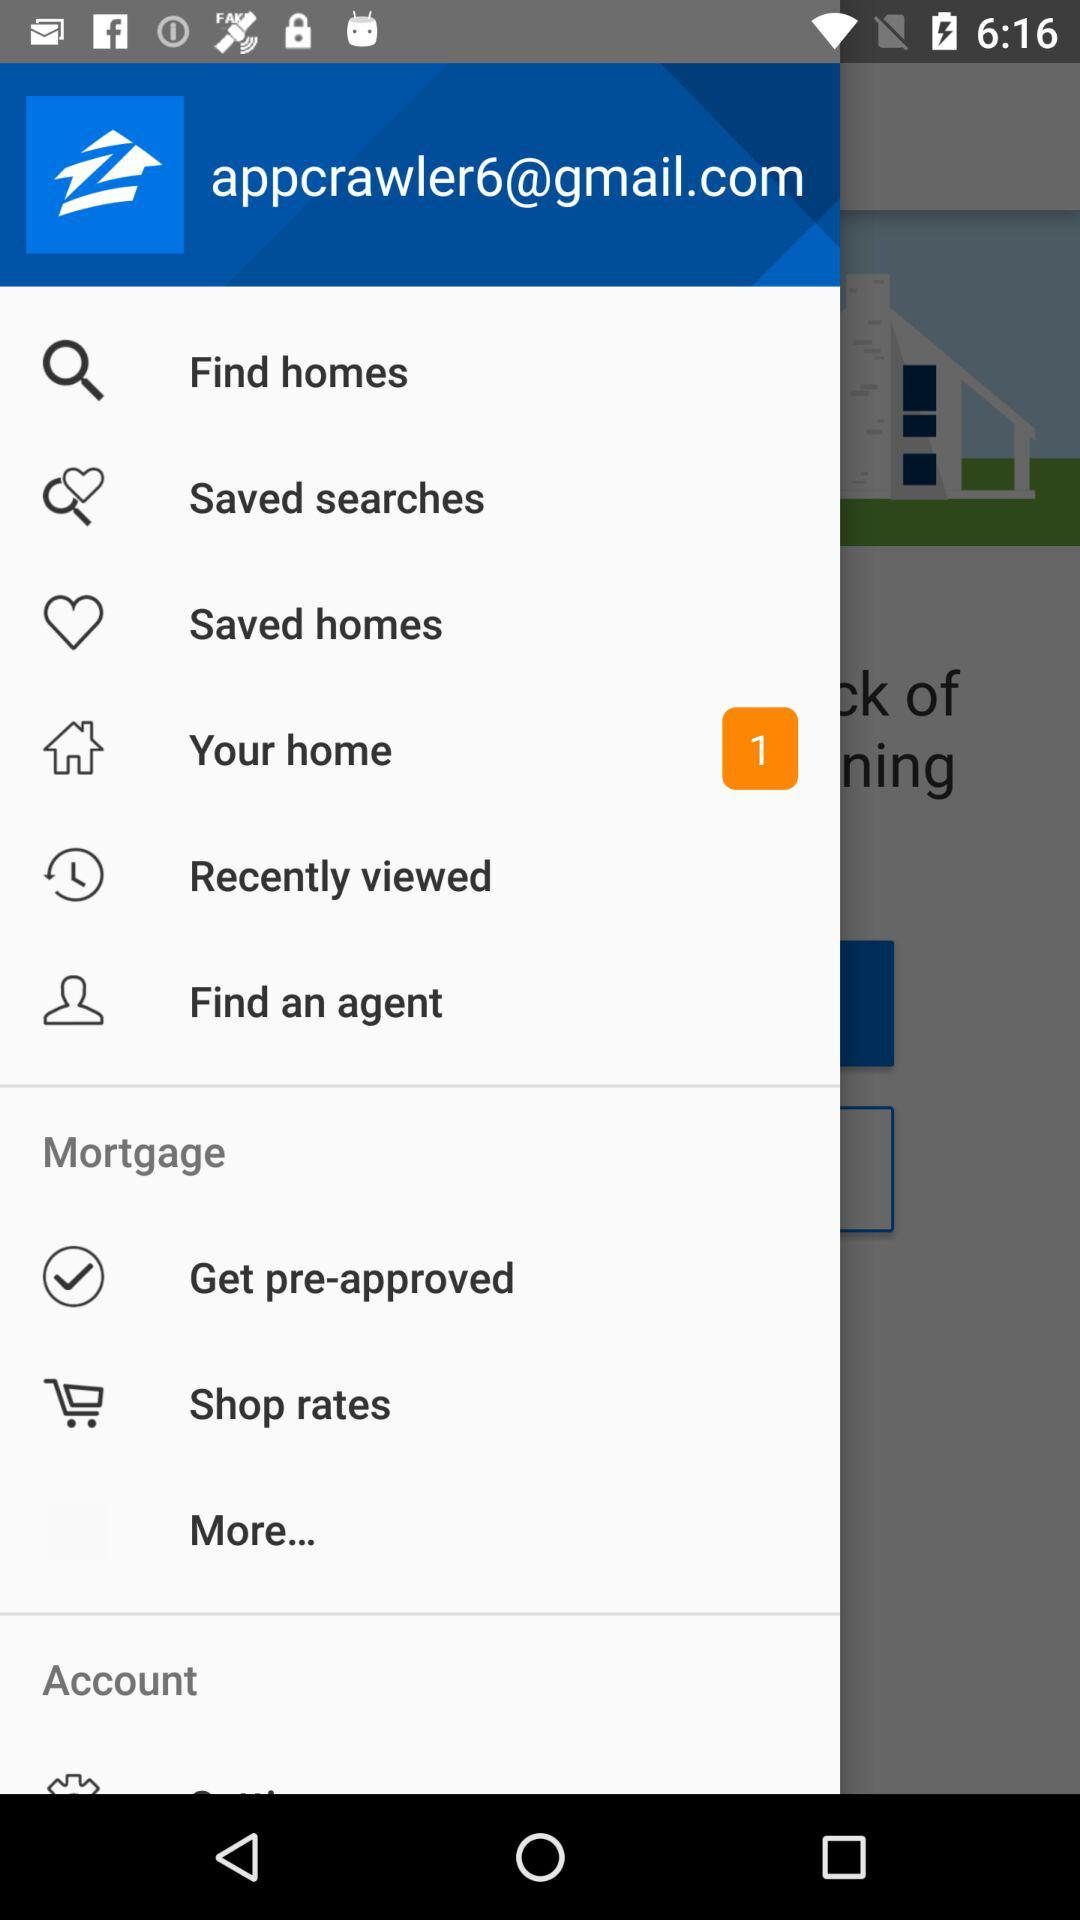How many unread notifications are there in "Your home"? There is 1 unread notification. 